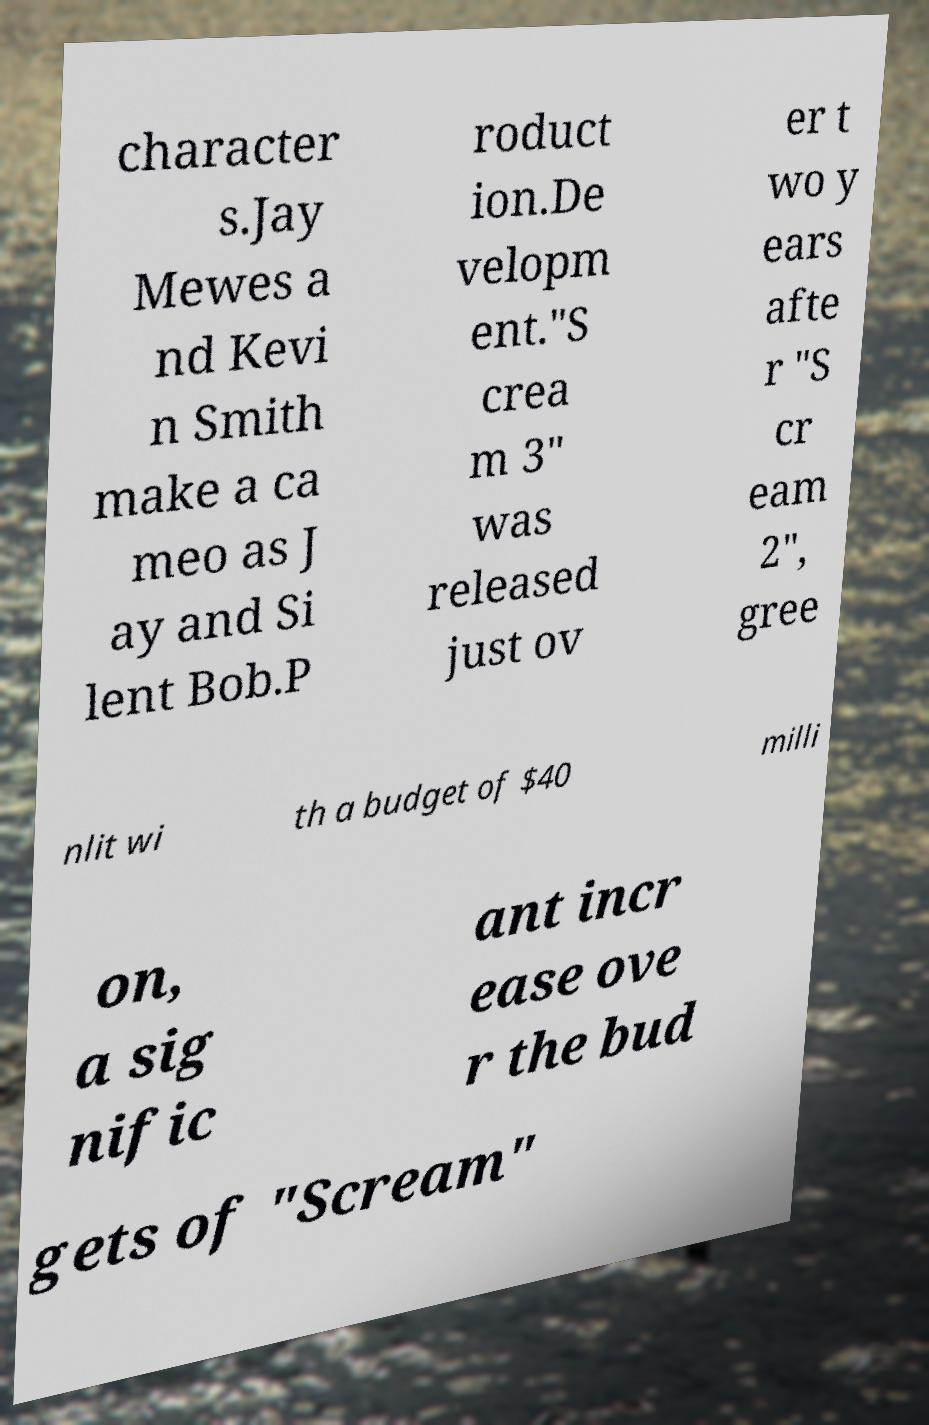Can you accurately transcribe the text from the provided image for me? character s.Jay Mewes a nd Kevi n Smith make a ca meo as J ay and Si lent Bob.P roduct ion.De velopm ent."S crea m 3" was released just ov er t wo y ears afte r "S cr eam 2", gree nlit wi th a budget of $40 milli on, a sig nific ant incr ease ove r the bud gets of "Scream" 